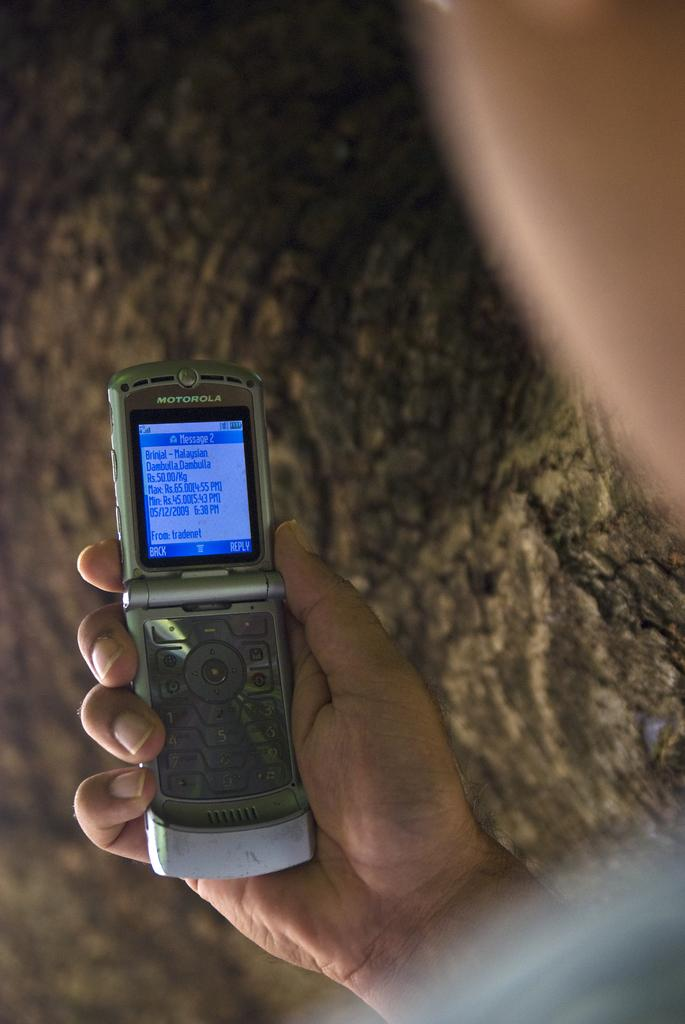<image>
Present a compact description of the photo's key features. MOTOROLA FLIP PHONE WITH BLUE ON BLUE TEXT SCREEN 